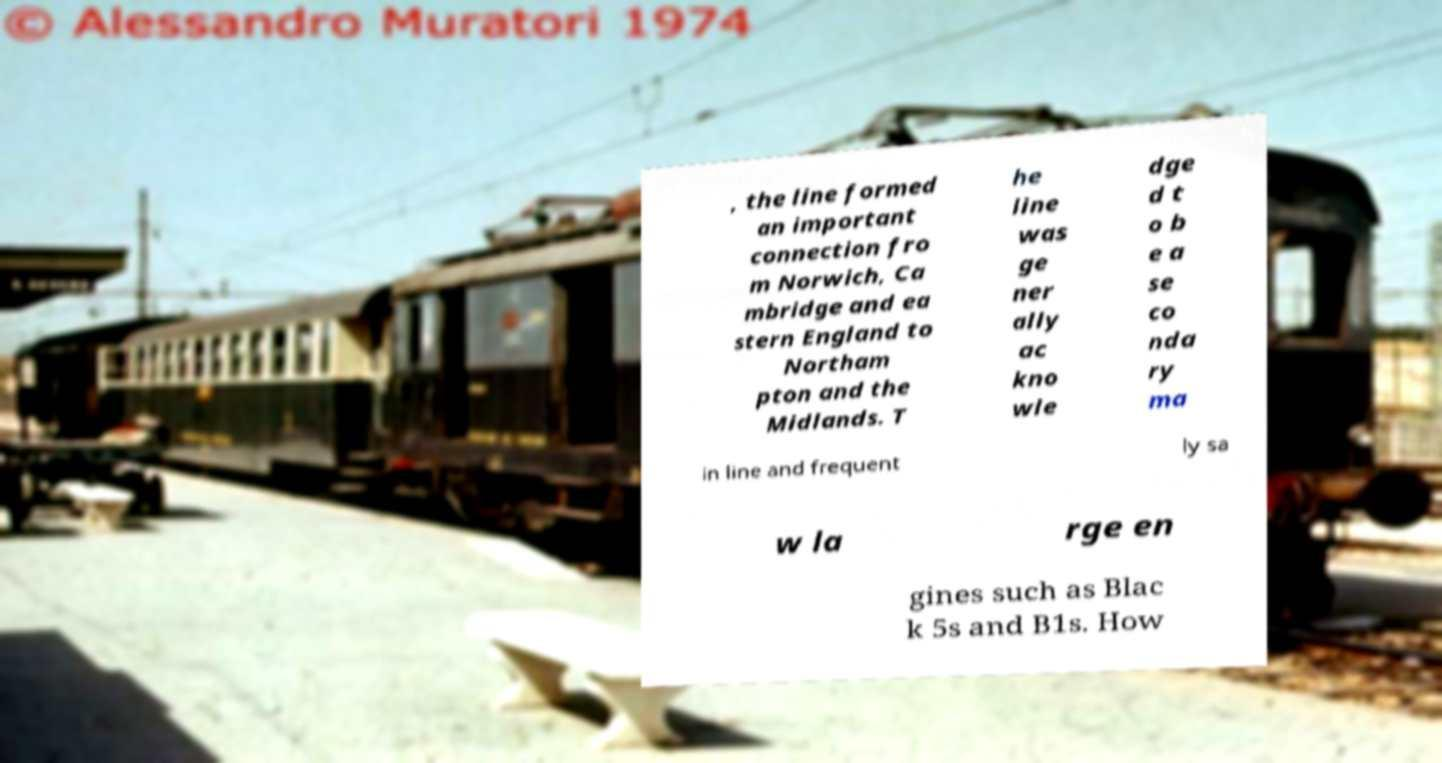What messages or text are displayed in this image? I need them in a readable, typed format. , the line formed an important connection fro m Norwich, Ca mbridge and ea stern England to Northam pton and the Midlands. T he line was ge ner ally ac kno wle dge d t o b e a se co nda ry ma in line and frequent ly sa w la rge en gines such as Blac k 5s and B1s. How 